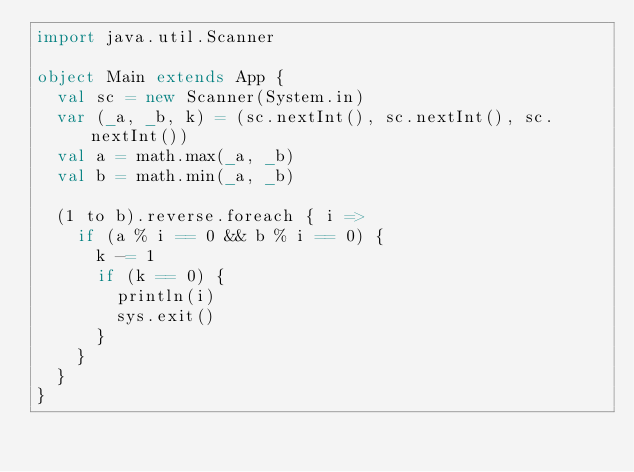Convert code to text. <code><loc_0><loc_0><loc_500><loc_500><_Scala_>import java.util.Scanner

object Main extends App {
  val sc = new Scanner(System.in)
  var (_a, _b, k) = (sc.nextInt(), sc.nextInt(), sc.nextInt())
  val a = math.max(_a, _b)
  val b = math.min(_a, _b)

  (1 to b).reverse.foreach { i =>
    if (a % i == 0 && b % i == 0) {
      k -= 1
      if (k == 0) {
        println(i)
        sys.exit()
      }
    }
  }
}</code> 